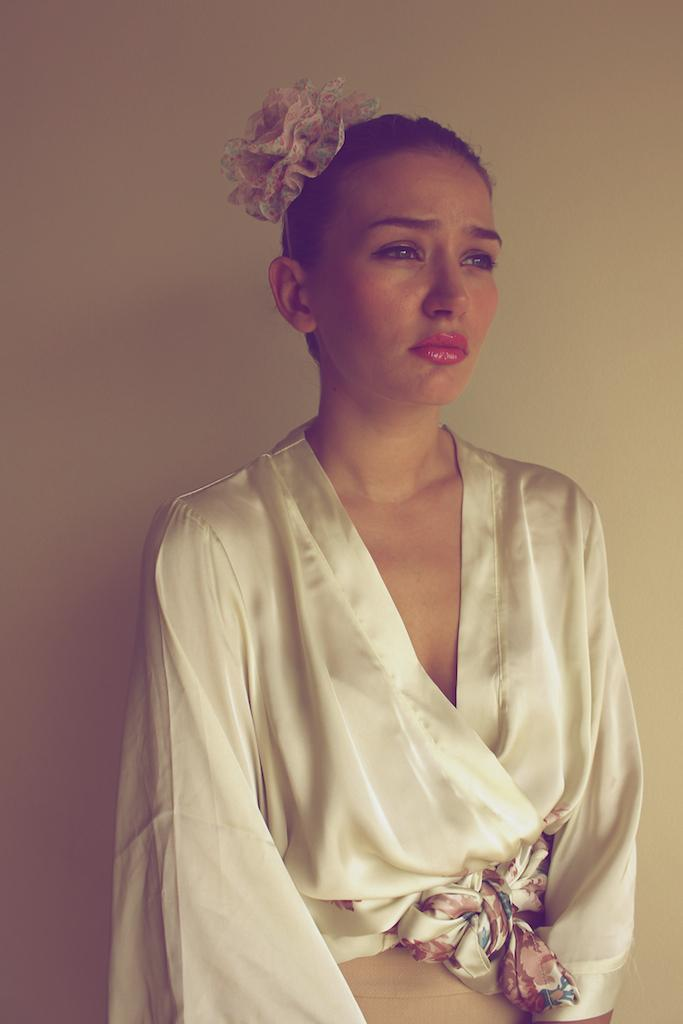What is the main subject of the image? There is a woman standing in the image. What can be seen in the background of the image? The background of the image is white. What type of fork is the woman using to stir the wax in the image? There is no fork or wax present in the image; it only features a woman standing in front of a white background. 